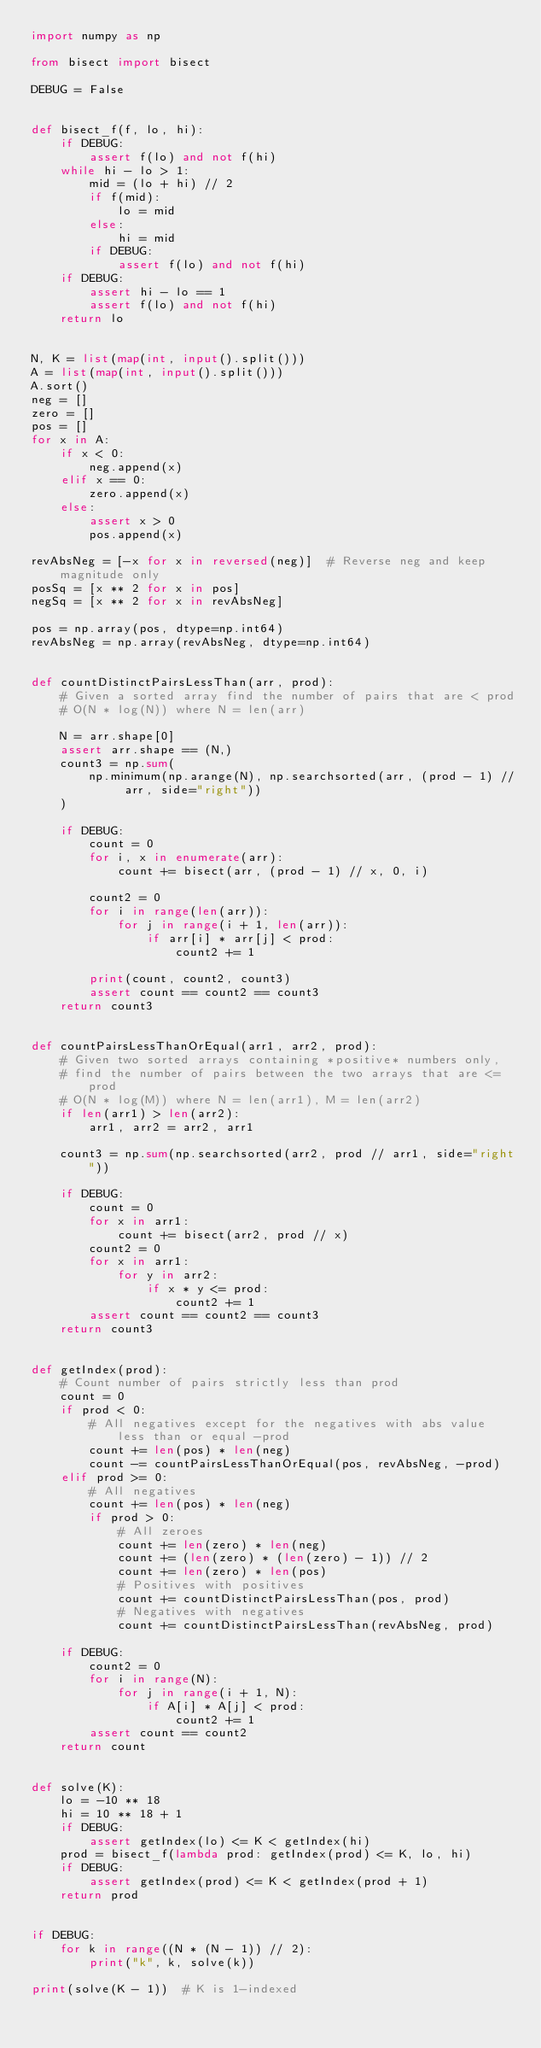Convert code to text. <code><loc_0><loc_0><loc_500><loc_500><_Python_>import numpy as np

from bisect import bisect

DEBUG = False


def bisect_f(f, lo, hi):
    if DEBUG:
        assert f(lo) and not f(hi)
    while hi - lo > 1:
        mid = (lo + hi) // 2
        if f(mid):
            lo = mid
        else:
            hi = mid
        if DEBUG:
            assert f(lo) and not f(hi)
    if DEBUG:
        assert hi - lo == 1
        assert f(lo) and not f(hi)
    return lo


N, K = list(map(int, input().split()))
A = list(map(int, input().split()))
A.sort()
neg = []
zero = []
pos = []
for x in A:
    if x < 0:
        neg.append(x)
    elif x == 0:
        zero.append(x)
    else:
        assert x > 0
        pos.append(x)

revAbsNeg = [-x for x in reversed(neg)]  # Reverse neg and keep magnitude only
posSq = [x ** 2 for x in pos]
negSq = [x ** 2 for x in revAbsNeg]

pos = np.array(pos, dtype=np.int64)
revAbsNeg = np.array(revAbsNeg, dtype=np.int64)


def countDistinctPairsLessThan(arr, prod):
    # Given a sorted array find the number of pairs that are < prod
    # O(N * log(N)) where N = len(arr)

    N = arr.shape[0]
    assert arr.shape == (N,)
    count3 = np.sum(
        np.minimum(np.arange(N), np.searchsorted(arr, (prod - 1) // arr, side="right"))
    )

    if DEBUG:
        count = 0
        for i, x in enumerate(arr):
            count += bisect(arr, (prod - 1) // x, 0, i)

        count2 = 0
        for i in range(len(arr)):
            for j in range(i + 1, len(arr)):
                if arr[i] * arr[j] < prod:
                    count2 += 1

        print(count, count2, count3)
        assert count == count2 == count3
    return count3


def countPairsLessThanOrEqual(arr1, arr2, prod):
    # Given two sorted arrays containing *positive* numbers only,
    # find the number of pairs between the two arrays that are <= prod
    # O(N * log(M)) where N = len(arr1), M = len(arr2)
    if len(arr1) > len(arr2):
        arr1, arr2 = arr2, arr1

    count3 = np.sum(np.searchsorted(arr2, prod // arr1, side="right"))

    if DEBUG:
        count = 0
        for x in arr1:
            count += bisect(arr2, prod // x)
        count2 = 0
        for x in arr1:
            for y in arr2:
                if x * y <= prod:
                    count2 += 1
        assert count == count2 == count3
    return count3


def getIndex(prod):
    # Count number of pairs strictly less than prod
    count = 0
    if prod < 0:
        # All negatives except for the negatives with abs value less than or equal -prod
        count += len(pos) * len(neg)
        count -= countPairsLessThanOrEqual(pos, revAbsNeg, -prod)
    elif prod >= 0:
        # All negatives
        count += len(pos) * len(neg)
        if prod > 0:
            # All zeroes
            count += len(zero) * len(neg)
            count += (len(zero) * (len(zero) - 1)) // 2
            count += len(zero) * len(pos)
            # Positives with positives
            count += countDistinctPairsLessThan(pos, prod)
            # Negatives with negatives
            count += countDistinctPairsLessThan(revAbsNeg, prod)

    if DEBUG:
        count2 = 0
        for i in range(N):
            for j in range(i + 1, N):
                if A[i] * A[j] < prod:
                    count2 += 1
        assert count == count2
    return count


def solve(K):
    lo = -10 ** 18
    hi = 10 ** 18 + 1
    if DEBUG:
        assert getIndex(lo) <= K < getIndex(hi)
    prod = bisect_f(lambda prod: getIndex(prod) <= K, lo, hi)
    if DEBUG:
        assert getIndex(prod) <= K < getIndex(prod + 1)
    return prod


if DEBUG:
    for k in range((N * (N - 1)) // 2):
        print("k", k, solve(k))

print(solve(K - 1))  # K is 1-indexed

</code> 